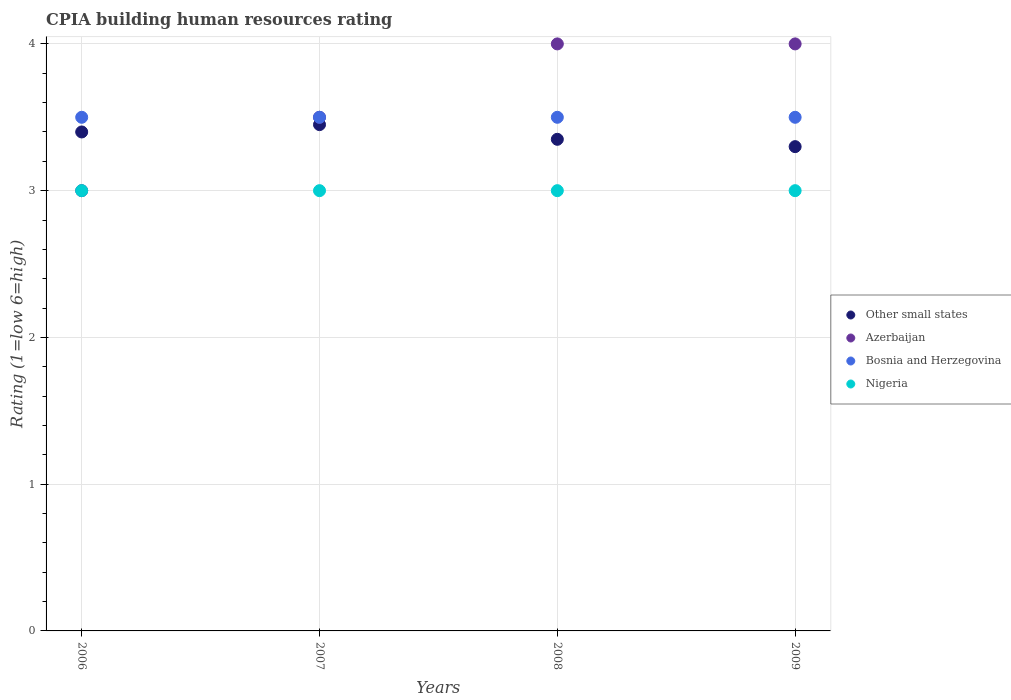Is the number of dotlines equal to the number of legend labels?
Ensure brevity in your answer.  Yes. What is the CPIA rating in Other small states in 2008?
Your answer should be very brief. 3.35. Across all years, what is the minimum CPIA rating in Other small states?
Offer a very short reply. 3.3. In which year was the CPIA rating in Other small states maximum?
Keep it short and to the point. 2007. In which year was the CPIA rating in Nigeria minimum?
Keep it short and to the point. 2006. What is the difference between the CPIA rating in Nigeria in 2007 and that in 2008?
Your answer should be very brief. 0. What is the average CPIA rating in Other small states per year?
Provide a succinct answer. 3.38. In the year 2007, what is the difference between the CPIA rating in Other small states and CPIA rating in Nigeria?
Give a very brief answer. 0.45. In how many years, is the CPIA rating in Azerbaijan greater than 2.6?
Provide a succinct answer. 4. What is the ratio of the CPIA rating in Azerbaijan in 2006 to that in 2009?
Offer a very short reply. 0.75. Is the CPIA rating in Nigeria in 2006 less than that in 2009?
Provide a short and direct response. No. Is the difference between the CPIA rating in Other small states in 2006 and 2007 greater than the difference between the CPIA rating in Nigeria in 2006 and 2007?
Make the answer very short. No. Is the sum of the CPIA rating in Nigeria in 2006 and 2008 greater than the maximum CPIA rating in Bosnia and Herzegovina across all years?
Provide a short and direct response. Yes. Is it the case that in every year, the sum of the CPIA rating in Other small states and CPIA rating in Azerbaijan  is greater than the sum of CPIA rating in Nigeria and CPIA rating in Bosnia and Herzegovina?
Provide a short and direct response. Yes. Is it the case that in every year, the sum of the CPIA rating in Nigeria and CPIA rating in Bosnia and Herzegovina  is greater than the CPIA rating in Other small states?
Give a very brief answer. Yes. Is the CPIA rating in Bosnia and Herzegovina strictly greater than the CPIA rating in Other small states over the years?
Your answer should be very brief. Yes. Is the CPIA rating in Other small states strictly less than the CPIA rating in Bosnia and Herzegovina over the years?
Keep it short and to the point. Yes. How many dotlines are there?
Your response must be concise. 4. What is the difference between two consecutive major ticks on the Y-axis?
Keep it short and to the point. 1. Are the values on the major ticks of Y-axis written in scientific E-notation?
Give a very brief answer. No. Does the graph contain any zero values?
Give a very brief answer. No. Does the graph contain grids?
Make the answer very short. Yes. How are the legend labels stacked?
Provide a succinct answer. Vertical. What is the title of the graph?
Ensure brevity in your answer.  CPIA building human resources rating. What is the label or title of the Y-axis?
Provide a succinct answer. Rating (1=low 6=high). What is the Rating (1=low 6=high) of Bosnia and Herzegovina in 2006?
Give a very brief answer. 3.5. What is the Rating (1=low 6=high) in Nigeria in 2006?
Your response must be concise. 3. What is the Rating (1=low 6=high) in Other small states in 2007?
Make the answer very short. 3.45. What is the Rating (1=low 6=high) of Nigeria in 2007?
Make the answer very short. 3. What is the Rating (1=low 6=high) in Other small states in 2008?
Provide a succinct answer. 3.35. What is the Rating (1=low 6=high) in Bosnia and Herzegovina in 2008?
Your response must be concise. 3.5. What is the Rating (1=low 6=high) in Bosnia and Herzegovina in 2009?
Offer a very short reply. 3.5. Across all years, what is the maximum Rating (1=low 6=high) of Other small states?
Make the answer very short. 3.45. Across all years, what is the minimum Rating (1=low 6=high) in Other small states?
Keep it short and to the point. 3.3. Across all years, what is the minimum Rating (1=low 6=high) of Azerbaijan?
Ensure brevity in your answer.  3. Across all years, what is the minimum Rating (1=low 6=high) of Nigeria?
Keep it short and to the point. 3. What is the total Rating (1=low 6=high) of Other small states in the graph?
Provide a short and direct response. 13.5. What is the total Rating (1=low 6=high) in Nigeria in the graph?
Give a very brief answer. 12. What is the difference between the Rating (1=low 6=high) of Other small states in 2006 and that in 2007?
Keep it short and to the point. -0.05. What is the difference between the Rating (1=low 6=high) of Azerbaijan in 2006 and that in 2007?
Ensure brevity in your answer.  -0.5. What is the difference between the Rating (1=low 6=high) in Bosnia and Herzegovina in 2006 and that in 2007?
Make the answer very short. 0. What is the difference between the Rating (1=low 6=high) in Other small states in 2006 and that in 2008?
Your answer should be very brief. 0.05. What is the difference between the Rating (1=low 6=high) in Azerbaijan in 2006 and that in 2008?
Provide a succinct answer. -1. What is the difference between the Rating (1=low 6=high) of Bosnia and Herzegovina in 2006 and that in 2008?
Keep it short and to the point. 0. What is the difference between the Rating (1=low 6=high) of Nigeria in 2006 and that in 2008?
Ensure brevity in your answer.  0. What is the difference between the Rating (1=low 6=high) in Nigeria in 2006 and that in 2009?
Your answer should be compact. 0. What is the difference between the Rating (1=low 6=high) in Bosnia and Herzegovina in 2007 and that in 2008?
Your answer should be compact. 0. What is the difference between the Rating (1=low 6=high) in Other small states in 2007 and that in 2009?
Give a very brief answer. 0.15. What is the difference between the Rating (1=low 6=high) in Nigeria in 2007 and that in 2009?
Give a very brief answer. 0. What is the difference between the Rating (1=low 6=high) in Other small states in 2008 and that in 2009?
Offer a very short reply. 0.05. What is the difference between the Rating (1=low 6=high) in Azerbaijan in 2008 and that in 2009?
Offer a very short reply. 0. What is the difference between the Rating (1=low 6=high) of Other small states in 2006 and the Rating (1=low 6=high) of Bosnia and Herzegovina in 2007?
Provide a succinct answer. -0.1. What is the difference between the Rating (1=low 6=high) of Azerbaijan in 2006 and the Rating (1=low 6=high) of Bosnia and Herzegovina in 2007?
Your answer should be compact. -0.5. What is the difference between the Rating (1=low 6=high) in Azerbaijan in 2006 and the Rating (1=low 6=high) in Nigeria in 2008?
Offer a very short reply. 0. What is the difference between the Rating (1=low 6=high) in Bosnia and Herzegovina in 2006 and the Rating (1=low 6=high) in Nigeria in 2008?
Make the answer very short. 0.5. What is the difference between the Rating (1=low 6=high) in Other small states in 2006 and the Rating (1=low 6=high) in Azerbaijan in 2009?
Keep it short and to the point. -0.6. What is the difference between the Rating (1=low 6=high) in Azerbaijan in 2006 and the Rating (1=low 6=high) in Bosnia and Herzegovina in 2009?
Offer a terse response. -0.5. What is the difference between the Rating (1=low 6=high) in Other small states in 2007 and the Rating (1=low 6=high) in Azerbaijan in 2008?
Make the answer very short. -0.55. What is the difference between the Rating (1=low 6=high) in Other small states in 2007 and the Rating (1=low 6=high) in Nigeria in 2008?
Offer a terse response. 0.45. What is the difference between the Rating (1=low 6=high) of Bosnia and Herzegovina in 2007 and the Rating (1=low 6=high) of Nigeria in 2008?
Ensure brevity in your answer.  0.5. What is the difference between the Rating (1=low 6=high) in Other small states in 2007 and the Rating (1=low 6=high) in Azerbaijan in 2009?
Give a very brief answer. -0.55. What is the difference between the Rating (1=low 6=high) of Other small states in 2007 and the Rating (1=low 6=high) of Bosnia and Herzegovina in 2009?
Your answer should be very brief. -0.05. What is the difference between the Rating (1=low 6=high) of Other small states in 2007 and the Rating (1=low 6=high) of Nigeria in 2009?
Ensure brevity in your answer.  0.45. What is the difference between the Rating (1=low 6=high) in Azerbaijan in 2007 and the Rating (1=low 6=high) in Nigeria in 2009?
Provide a succinct answer. 0.5. What is the difference between the Rating (1=low 6=high) of Other small states in 2008 and the Rating (1=low 6=high) of Azerbaijan in 2009?
Offer a very short reply. -0.65. What is the difference between the Rating (1=low 6=high) of Other small states in 2008 and the Rating (1=low 6=high) of Bosnia and Herzegovina in 2009?
Your answer should be very brief. -0.15. What is the difference between the Rating (1=low 6=high) in Azerbaijan in 2008 and the Rating (1=low 6=high) in Bosnia and Herzegovina in 2009?
Your response must be concise. 0.5. What is the difference between the Rating (1=low 6=high) in Azerbaijan in 2008 and the Rating (1=low 6=high) in Nigeria in 2009?
Keep it short and to the point. 1. What is the average Rating (1=low 6=high) in Other small states per year?
Your answer should be very brief. 3.38. What is the average Rating (1=low 6=high) in Azerbaijan per year?
Offer a very short reply. 3.62. In the year 2006, what is the difference between the Rating (1=low 6=high) of Other small states and Rating (1=low 6=high) of Bosnia and Herzegovina?
Ensure brevity in your answer.  -0.1. In the year 2006, what is the difference between the Rating (1=low 6=high) in Azerbaijan and Rating (1=low 6=high) in Nigeria?
Offer a very short reply. 0. In the year 2007, what is the difference between the Rating (1=low 6=high) in Other small states and Rating (1=low 6=high) in Bosnia and Herzegovina?
Provide a short and direct response. -0.05. In the year 2007, what is the difference between the Rating (1=low 6=high) of Other small states and Rating (1=low 6=high) of Nigeria?
Provide a succinct answer. 0.45. In the year 2007, what is the difference between the Rating (1=low 6=high) in Azerbaijan and Rating (1=low 6=high) in Nigeria?
Keep it short and to the point. 0.5. In the year 2008, what is the difference between the Rating (1=low 6=high) in Other small states and Rating (1=low 6=high) in Azerbaijan?
Offer a terse response. -0.65. In the year 2008, what is the difference between the Rating (1=low 6=high) in Other small states and Rating (1=low 6=high) in Nigeria?
Ensure brevity in your answer.  0.35. In the year 2008, what is the difference between the Rating (1=low 6=high) in Azerbaijan and Rating (1=low 6=high) in Bosnia and Herzegovina?
Provide a succinct answer. 0.5. In the year 2008, what is the difference between the Rating (1=low 6=high) in Azerbaijan and Rating (1=low 6=high) in Nigeria?
Your answer should be compact. 1. In the year 2008, what is the difference between the Rating (1=low 6=high) of Bosnia and Herzegovina and Rating (1=low 6=high) of Nigeria?
Your answer should be very brief. 0.5. In the year 2009, what is the difference between the Rating (1=low 6=high) in Other small states and Rating (1=low 6=high) in Azerbaijan?
Make the answer very short. -0.7. In the year 2009, what is the difference between the Rating (1=low 6=high) of Other small states and Rating (1=low 6=high) of Nigeria?
Ensure brevity in your answer.  0.3. In the year 2009, what is the difference between the Rating (1=low 6=high) in Azerbaijan and Rating (1=low 6=high) in Nigeria?
Ensure brevity in your answer.  1. What is the ratio of the Rating (1=low 6=high) of Other small states in 2006 to that in 2007?
Your response must be concise. 0.99. What is the ratio of the Rating (1=low 6=high) in Bosnia and Herzegovina in 2006 to that in 2007?
Offer a very short reply. 1. What is the ratio of the Rating (1=low 6=high) of Nigeria in 2006 to that in 2007?
Your answer should be compact. 1. What is the ratio of the Rating (1=low 6=high) in Other small states in 2006 to that in 2008?
Your answer should be very brief. 1.01. What is the ratio of the Rating (1=low 6=high) of Azerbaijan in 2006 to that in 2008?
Your answer should be compact. 0.75. What is the ratio of the Rating (1=low 6=high) in Nigeria in 2006 to that in 2008?
Provide a succinct answer. 1. What is the ratio of the Rating (1=low 6=high) in Other small states in 2006 to that in 2009?
Make the answer very short. 1.03. What is the ratio of the Rating (1=low 6=high) of Bosnia and Herzegovina in 2006 to that in 2009?
Your answer should be compact. 1. What is the ratio of the Rating (1=low 6=high) in Other small states in 2007 to that in 2008?
Your answer should be compact. 1.03. What is the ratio of the Rating (1=low 6=high) in Other small states in 2007 to that in 2009?
Provide a short and direct response. 1.05. What is the ratio of the Rating (1=low 6=high) in Azerbaijan in 2007 to that in 2009?
Provide a short and direct response. 0.88. What is the ratio of the Rating (1=low 6=high) of Bosnia and Herzegovina in 2007 to that in 2009?
Offer a terse response. 1. What is the ratio of the Rating (1=low 6=high) in Nigeria in 2007 to that in 2009?
Offer a terse response. 1. What is the ratio of the Rating (1=low 6=high) in Other small states in 2008 to that in 2009?
Provide a succinct answer. 1.02. What is the ratio of the Rating (1=low 6=high) of Nigeria in 2008 to that in 2009?
Your answer should be compact. 1. What is the difference between the highest and the second highest Rating (1=low 6=high) of Nigeria?
Provide a short and direct response. 0. What is the difference between the highest and the lowest Rating (1=low 6=high) of Other small states?
Ensure brevity in your answer.  0.15. What is the difference between the highest and the lowest Rating (1=low 6=high) in Azerbaijan?
Keep it short and to the point. 1. What is the difference between the highest and the lowest Rating (1=low 6=high) in Bosnia and Herzegovina?
Your answer should be compact. 0. 